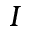<formula> <loc_0><loc_0><loc_500><loc_500>I</formula> 